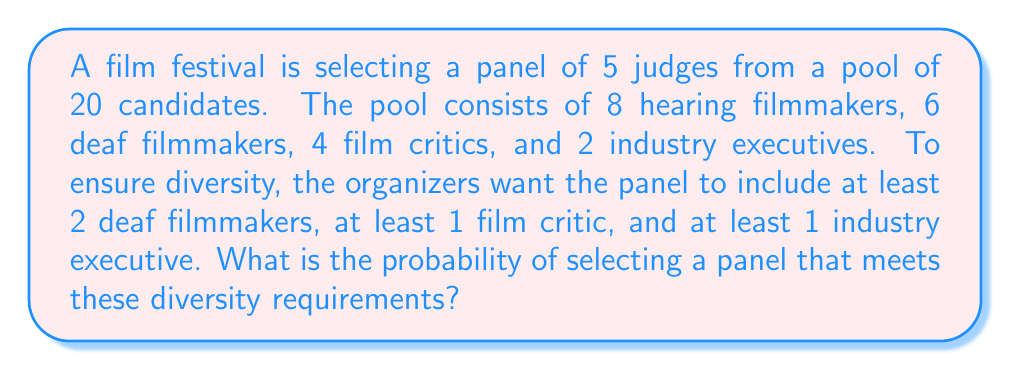What is the answer to this math problem? Let's approach this step-by-step:

1) First, we need to calculate the total number of ways to select 5 judges from 20 candidates:
   $$\binom{20}{5} = \frac{20!}{5!(20-5)!} = 15504$$

2) Now, we need to calculate the number of ways to select a panel that meets the diversity requirements:

   a) Select 2 deaf filmmakers: $\binom{6}{2}$
   b) Select 1 film critic: $\binom{4}{1}$
   c) Select 1 industry executive: $\binom{2}{1}$
   d) Select 1 more from the remaining candidates: $\binom{20-2-1-1}{1} = \binom{16}{1}$

3) Multiply these together:
   $$\binom{6}{2} \cdot \binom{4}{1} \cdot \binom{2}{1} \cdot \binom{16}{1} = 15 \cdot 4 \cdot 2 \cdot 16 = 1920$$

4) However, this count includes cases where we might have selected more than 2 deaf filmmakers. We need to add these:

   e) Select 3 deaf filmmakers: $\binom{6}{3} \cdot \binom{4}{1} \cdot \binom{2}{1} = 20 \cdot 4 \cdot 2 = 160$
   f) Select 4 deaf filmmakers: $\binom{6}{4} \cdot \binom{4}{1} \cdot \binom{2}{1} = 15 \cdot 4 \cdot 2 = 120$

5) Total favorable outcomes: $1920 + 160 + 120 = 2200$

6) Probability = (Favorable outcomes) / (Total outcomes)
   $$P = \frac{2200}{15504} = \frac{275}{1938} \approx 0.1419$$
Answer: $\frac{275}{1938}$ 